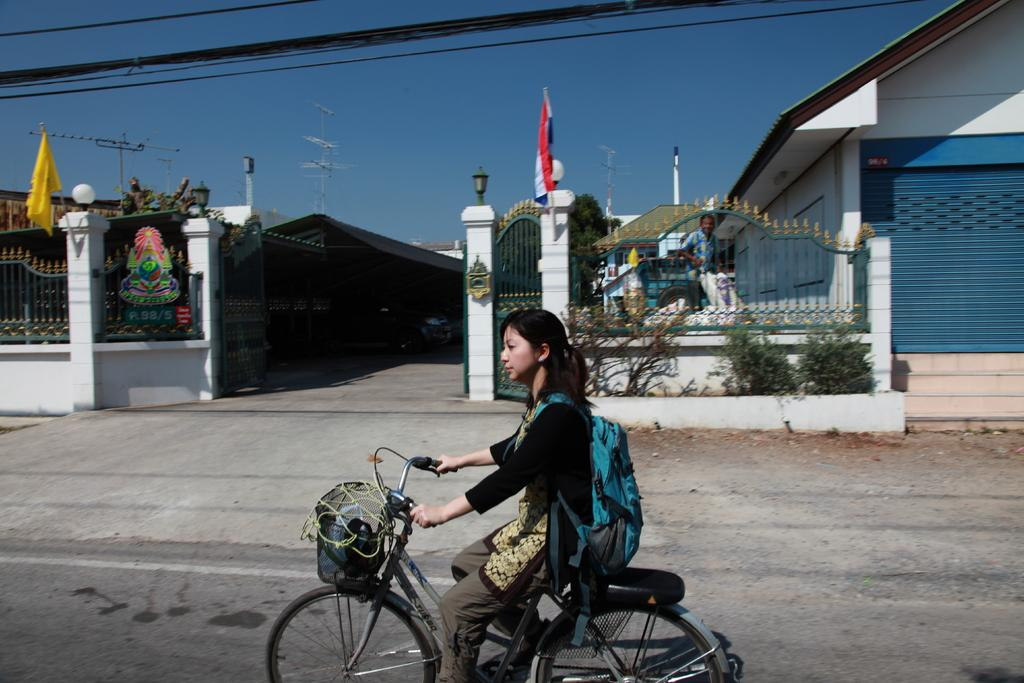Who is the main subject in the image? There is a woman in the image. What is the woman doing in the image? The woman is riding a bicycle in the image. Where is the woman riding her bicycle? The bicycle is on a road in the image. What else can be seen in the image? There is a house, a fence, and a flag with a pole in the image. Can you describe the person in the image? Yes, there is a person in the image, but it is not clear if it is a different person or the same woman. What is visible in the background of the image? The sky is visible in the background of the image. What type of crayon is the woman using to draw on the floor in the image? There is no crayon or drawing activity visible in the image. 